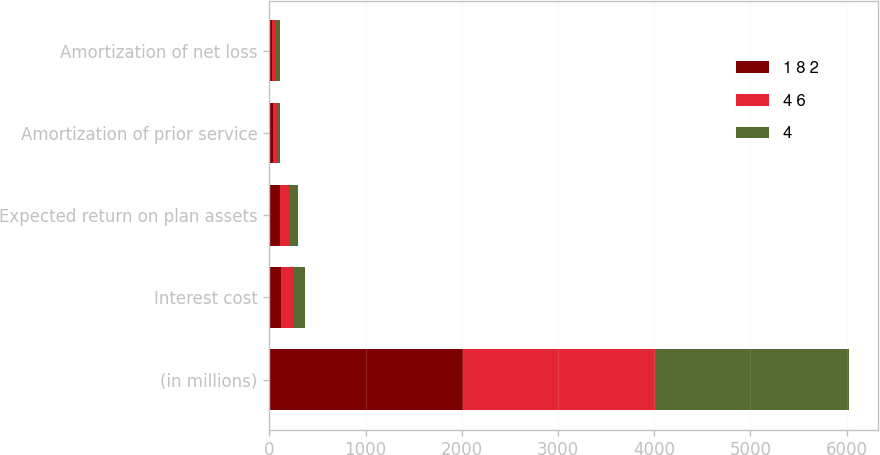Convert chart. <chart><loc_0><loc_0><loc_500><loc_500><stacked_bar_chart><ecel><fcel>(in millions)<fcel>Interest cost<fcel>Expected return on plan assets<fcel>Amortization of prior service<fcel>Amortization of net loss<nl><fcel>1 8 2<fcel>2011<fcel>121<fcel>111<fcel>36<fcel>27<nl><fcel>4 6<fcel>2010<fcel>127<fcel>101<fcel>38<fcel>36<nl><fcel>4<fcel>2009<fcel>122<fcel>81<fcel>34<fcel>45<nl></chart> 